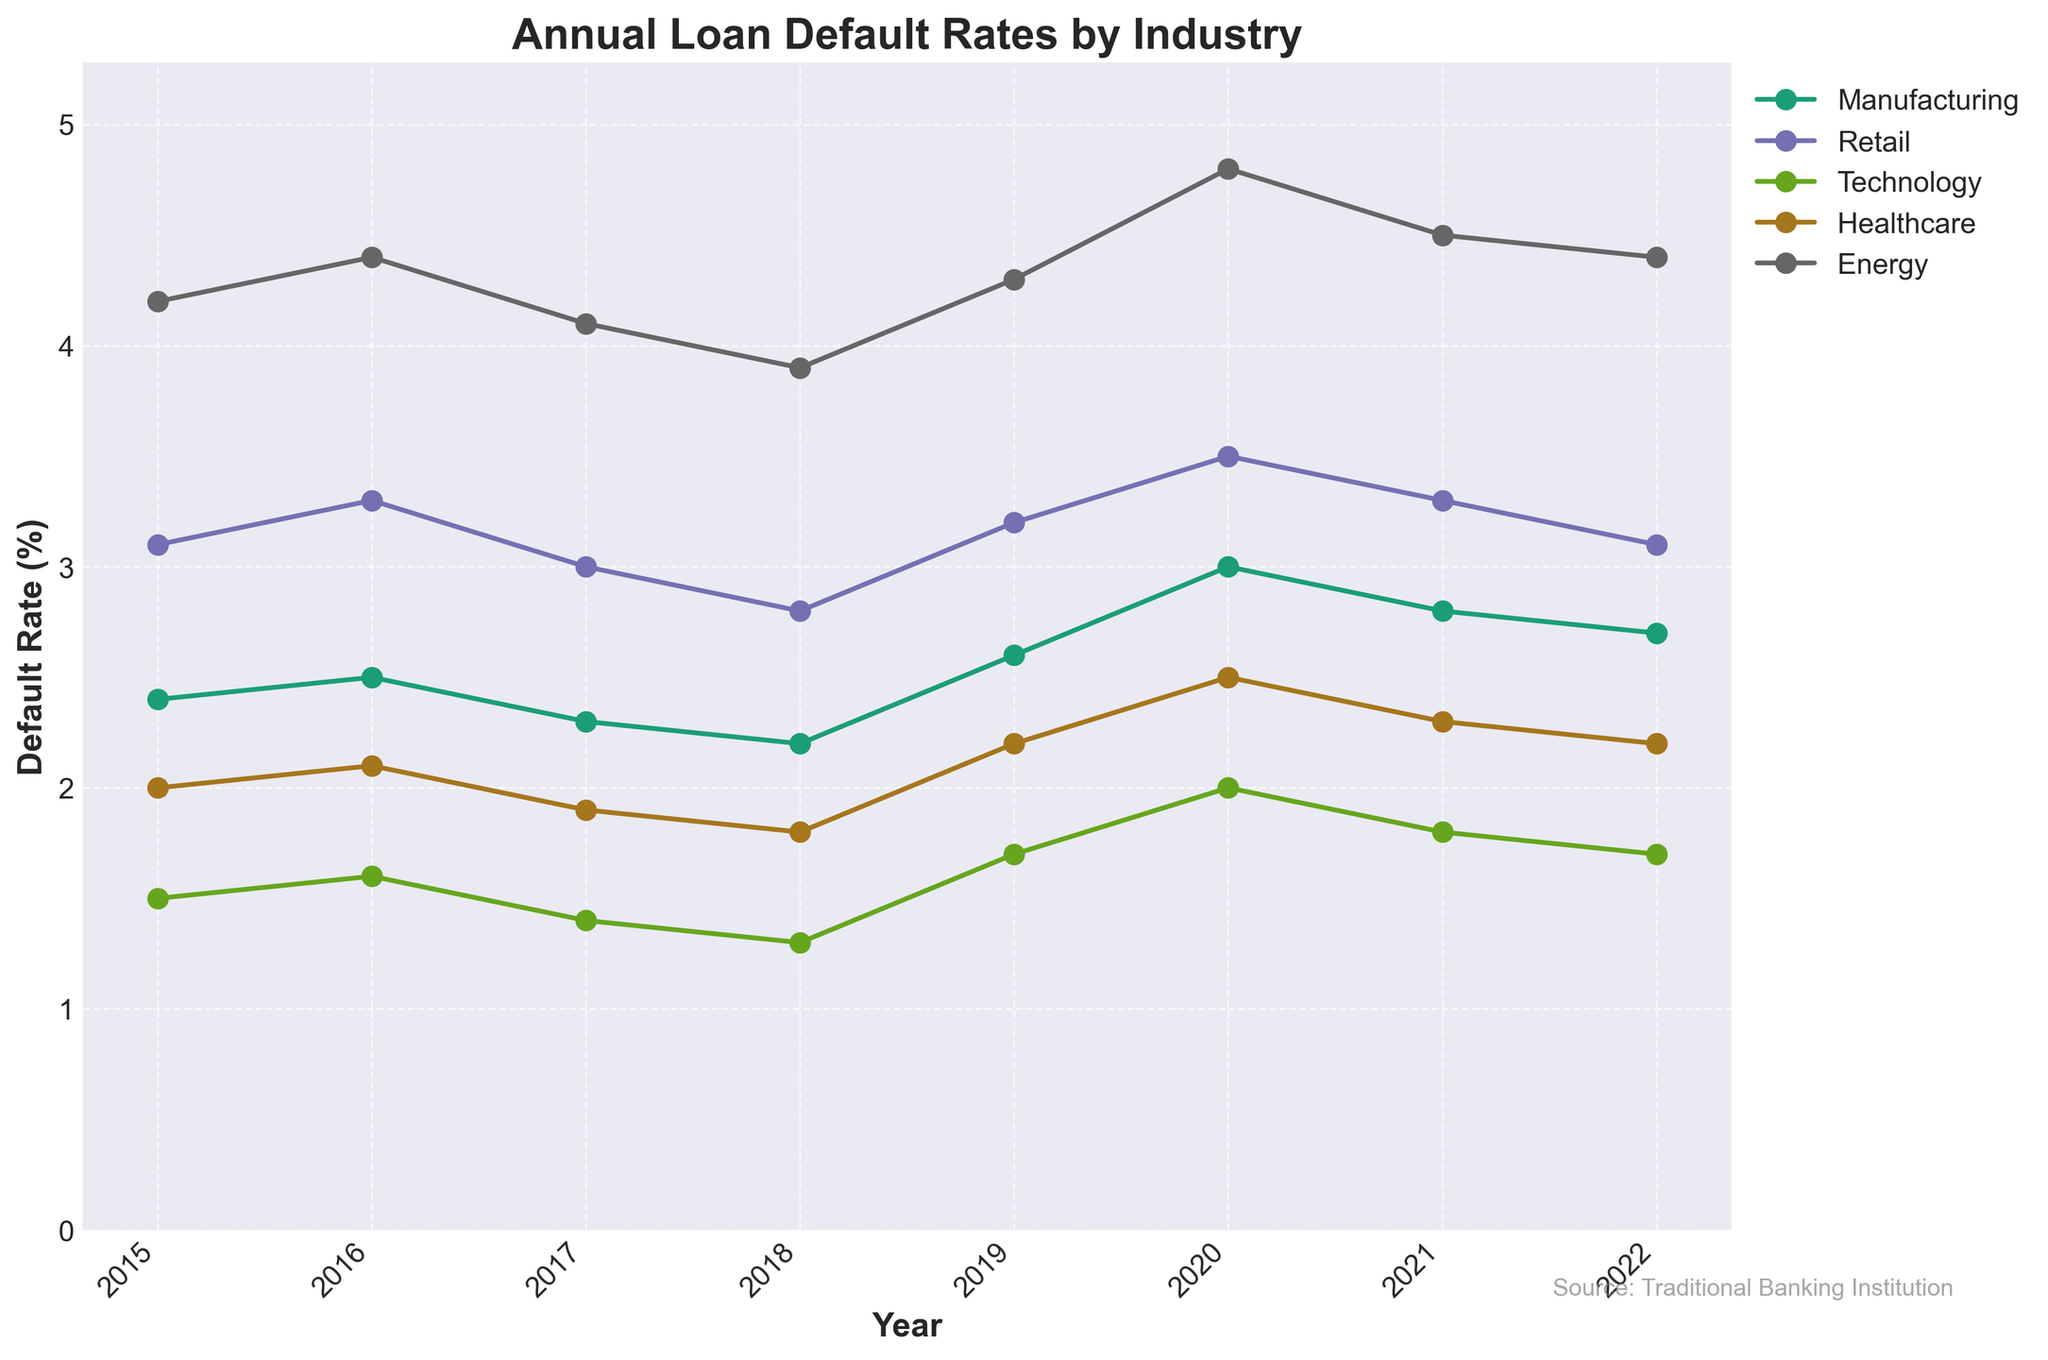What's the title of the plot? The title of the plot is located at the top center and provides an overview of the information presented in the plot.
Answer: Annual Loan Default Rates by Industry What is the default rate for the Retail industry in 2020? Locate the marker for the Retail industry on the plot at the year 2020, then trace vertically to read the default rate value.
Answer: 3.5% Which industry had the highest default rate in 2017? Identify the data points for each industry in 2017 and compare their positions on the y-axis to determine which one is highest.
Answer: Energy What trend do you observe for the Technology industry from 2015 to 2022? Examine the markers for the Technology industry across the years and observe their positional changes to determine the overall trend.
Answer: Decreasing Which industry shows the most volatility in default rates over the years? Look at the lines representing each industry's default rates and compare their fluctuations over the years to identify the most volatile.
Answer: Energy What is the average default rate for the Manufacturing industry across all years? Sum the default rates for the Manufacturing industry over all the years and divide by the number of years provided (8).
Answer: (2.4 + 2.5 + 2.3 + 2.2 + 2.6 + 3.0 + 2.8 + 2.7) / 8 = 2.56% How does the default rate for Healthcare in 2022 compare to its rate in 2015? Locate the markers for Healthcare in 2015 and 2022, then compare their values.
Answer: Increased Between 2019 and 2021, which industry saw the largest increase in default rates? Compute the difference in default rates for each industry between 2019 and 2021 and identify the largest value.
Answer: Technology, 0.3% Which industry had the lowest average default rate over the entire period? Calculate the average default rate for each industry by summing their default rates over the years and then comparing.
Answer: Technology Is there a year where all industries had an increase in default rates compared to the previous year? Compare the default rates of each industry year-over-year to identify if there is a year where all industries saw an increase.
Answer: 2020 